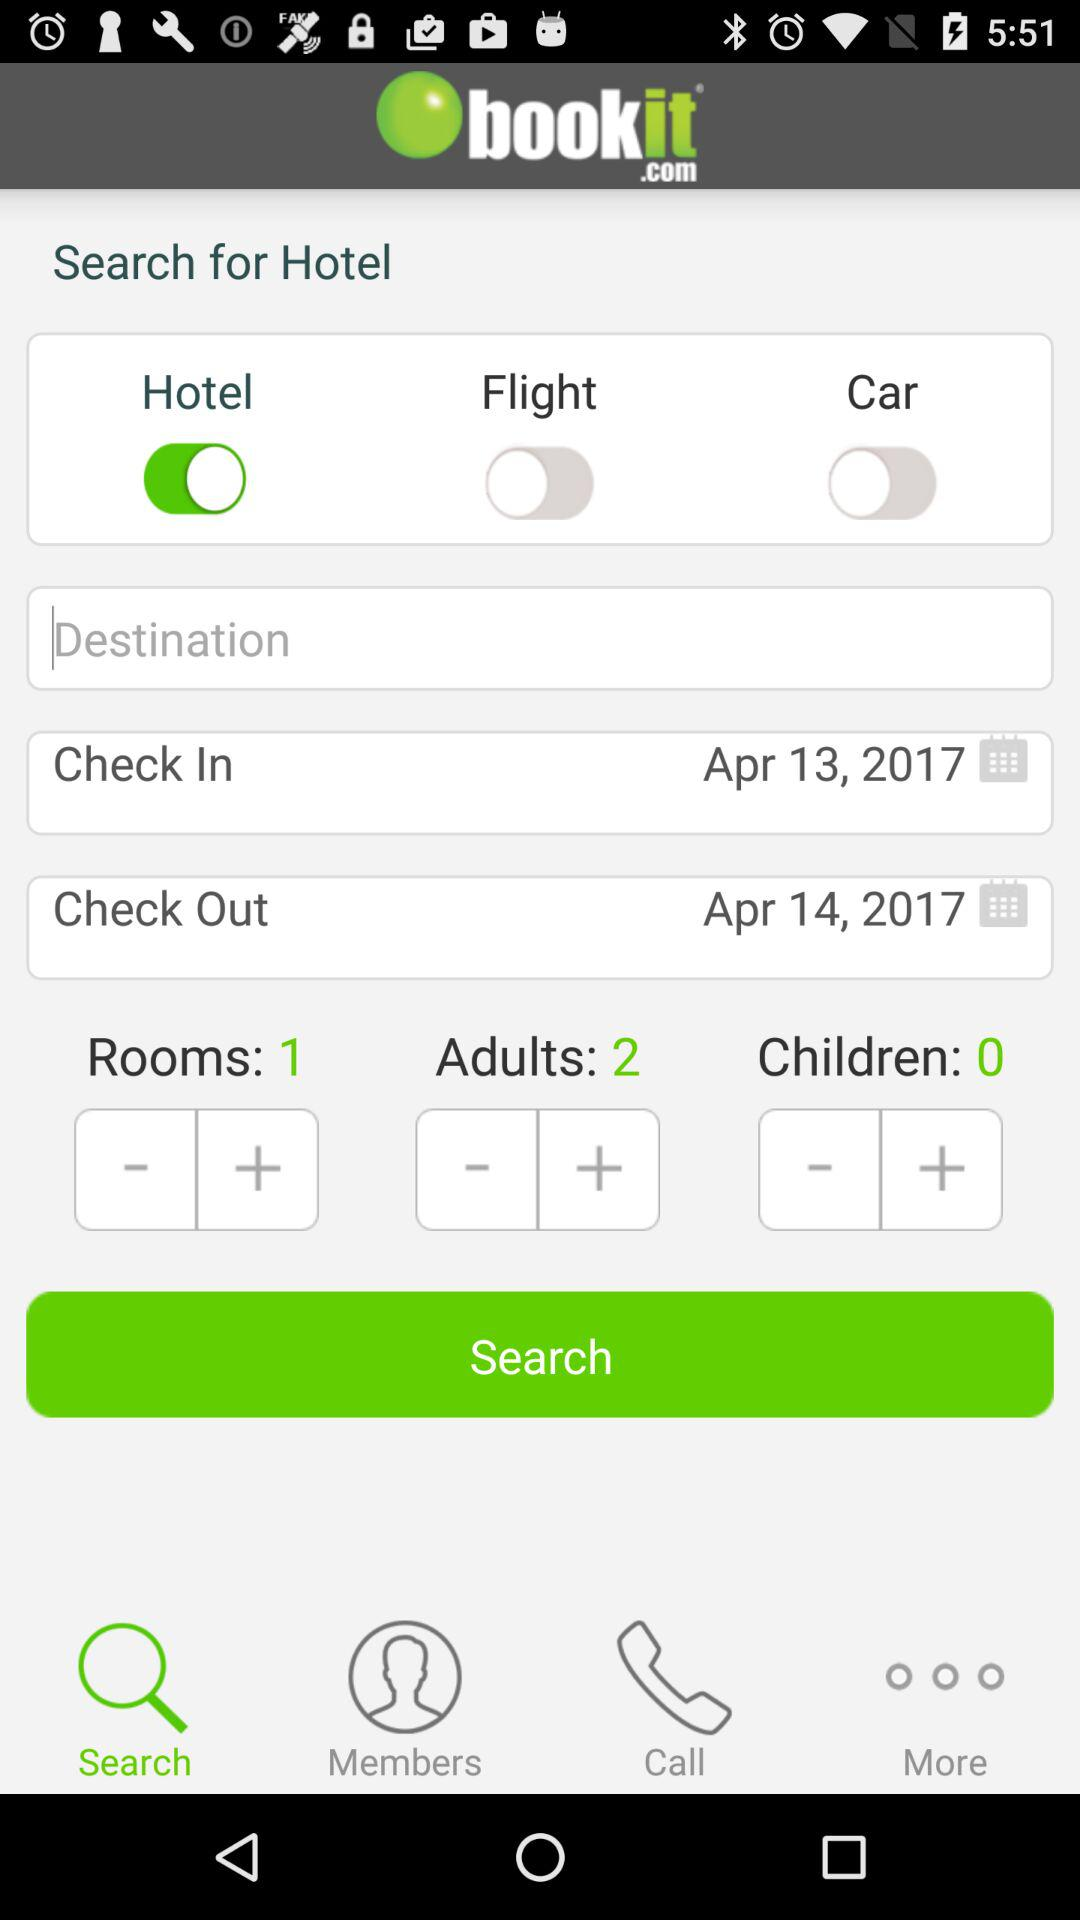How many children are there? There are 0 children. 